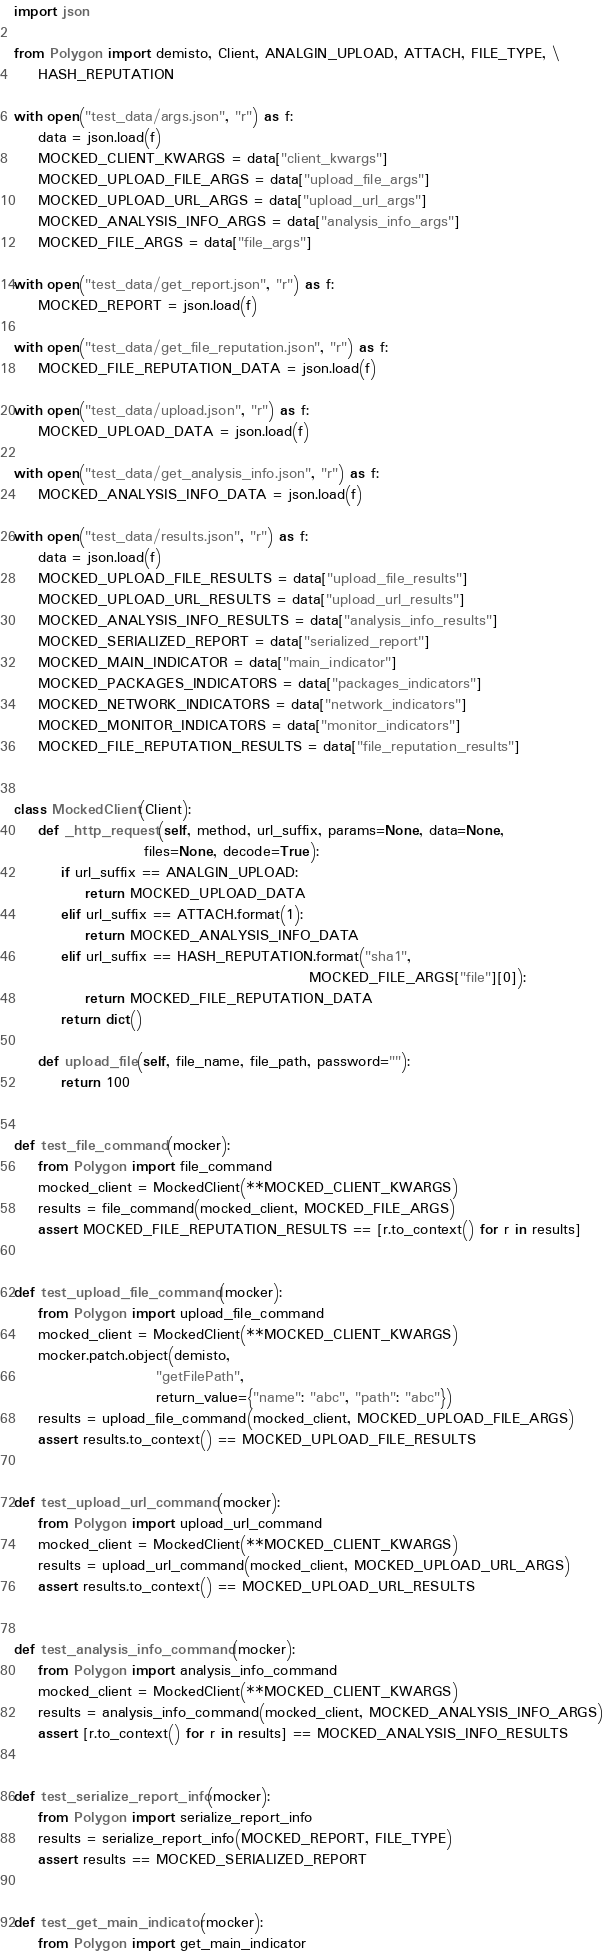<code> <loc_0><loc_0><loc_500><loc_500><_Python_>import json

from Polygon import demisto, Client, ANALGIN_UPLOAD, ATTACH, FILE_TYPE, \
    HASH_REPUTATION

with open("test_data/args.json", "r") as f:
    data = json.load(f)
    MOCKED_CLIENT_KWARGS = data["client_kwargs"]
    MOCKED_UPLOAD_FILE_ARGS = data["upload_file_args"]
    MOCKED_UPLOAD_URL_ARGS = data["upload_url_args"]
    MOCKED_ANALYSIS_INFO_ARGS = data["analysis_info_args"]
    MOCKED_FILE_ARGS = data["file_args"]

with open("test_data/get_report.json", "r") as f:
    MOCKED_REPORT = json.load(f)

with open("test_data/get_file_reputation.json", "r") as f:
    MOCKED_FILE_REPUTATION_DATA = json.load(f)

with open("test_data/upload.json", "r") as f:
    MOCKED_UPLOAD_DATA = json.load(f)

with open("test_data/get_analysis_info.json", "r") as f:
    MOCKED_ANALYSIS_INFO_DATA = json.load(f)

with open("test_data/results.json", "r") as f:
    data = json.load(f)
    MOCKED_UPLOAD_FILE_RESULTS = data["upload_file_results"]
    MOCKED_UPLOAD_URL_RESULTS = data["upload_url_results"]
    MOCKED_ANALYSIS_INFO_RESULTS = data["analysis_info_results"]
    MOCKED_SERIALIZED_REPORT = data["serialized_report"]
    MOCKED_MAIN_INDICATOR = data["main_indicator"]
    MOCKED_PACKAGES_INDICATORS = data["packages_indicators"]
    MOCKED_NETWORK_INDICATORS = data["network_indicators"]
    MOCKED_MONITOR_INDICATORS = data["monitor_indicators"]
    MOCKED_FILE_REPUTATION_RESULTS = data["file_reputation_results"]


class MockedClient(Client):
    def _http_request(self, method, url_suffix, params=None, data=None,
                      files=None, decode=True):
        if url_suffix == ANALGIN_UPLOAD:
            return MOCKED_UPLOAD_DATA
        elif url_suffix == ATTACH.format(1):
            return MOCKED_ANALYSIS_INFO_DATA
        elif url_suffix == HASH_REPUTATION.format("sha1",
                                                  MOCKED_FILE_ARGS["file"][0]):
            return MOCKED_FILE_REPUTATION_DATA
        return dict()

    def upload_file(self, file_name, file_path, password=""):
        return 100


def test_file_command(mocker):
    from Polygon import file_command
    mocked_client = MockedClient(**MOCKED_CLIENT_KWARGS)
    results = file_command(mocked_client, MOCKED_FILE_ARGS)
    assert MOCKED_FILE_REPUTATION_RESULTS == [r.to_context() for r in results]


def test_upload_file_command(mocker):
    from Polygon import upload_file_command
    mocked_client = MockedClient(**MOCKED_CLIENT_KWARGS)
    mocker.patch.object(demisto,
                        "getFilePath",
                        return_value={"name": "abc", "path": "abc"})
    results = upload_file_command(mocked_client, MOCKED_UPLOAD_FILE_ARGS)
    assert results.to_context() == MOCKED_UPLOAD_FILE_RESULTS


def test_upload_url_command(mocker):
    from Polygon import upload_url_command
    mocked_client = MockedClient(**MOCKED_CLIENT_KWARGS)
    results = upload_url_command(mocked_client, MOCKED_UPLOAD_URL_ARGS)
    assert results.to_context() == MOCKED_UPLOAD_URL_RESULTS


def test_analysis_info_command(mocker):
    from Polygon import analysis_info_command
    mocked_client = MockedClient(**MOCKED_CLIENT_KWARGS)
    results = analysis_info_command(mocked_client, MOCKED_ANALYSIS_INFO_ARGS)
    assert [r.to_context() for r in results] == MOCKED_ANALYSIS_INFO_RESULTS


def test_serialize_report_info(mocker):
    from Polygon import serialize_report_info
    results = serialize_report_info(MOCKED_REPORT, FILE_TYPE)
    assert results == MOCKED_SERIALIZED_REPORT


def test_get_main_indicator(mocker):
    from Polygon import get_main_indicator</code> 